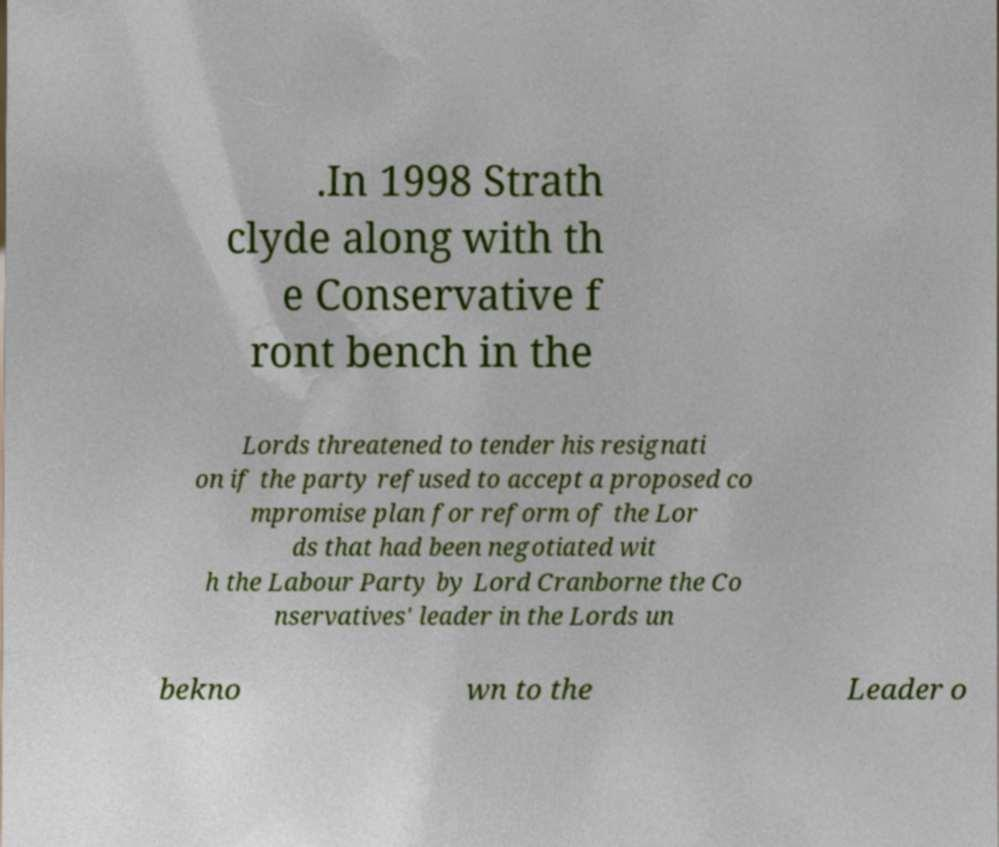Please read and relay the text visible in this image. What does it say? .In 1998 Strath clyde along with th e Conservative f ront bench in the Lords threatened to tender his resignati on if the party refused to accept a proposed co mpromise plan for reform of the Lor ds that had been negotiated wit h the Labour Party by Lord Cranborne the Co nservatives' leader in the Lords un bekno wn to the Leader o 